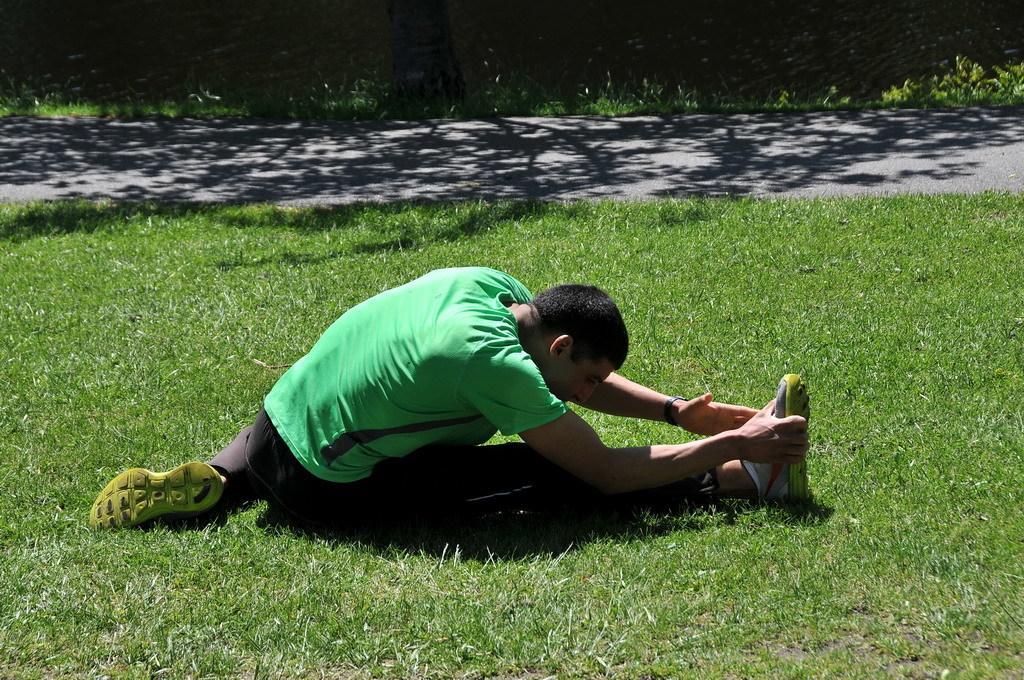In one or two sentences, can you explain what this image depicts? In this image a man wearing green T-shirt, black pant doing yoga in a garden, in the background there is a road. 